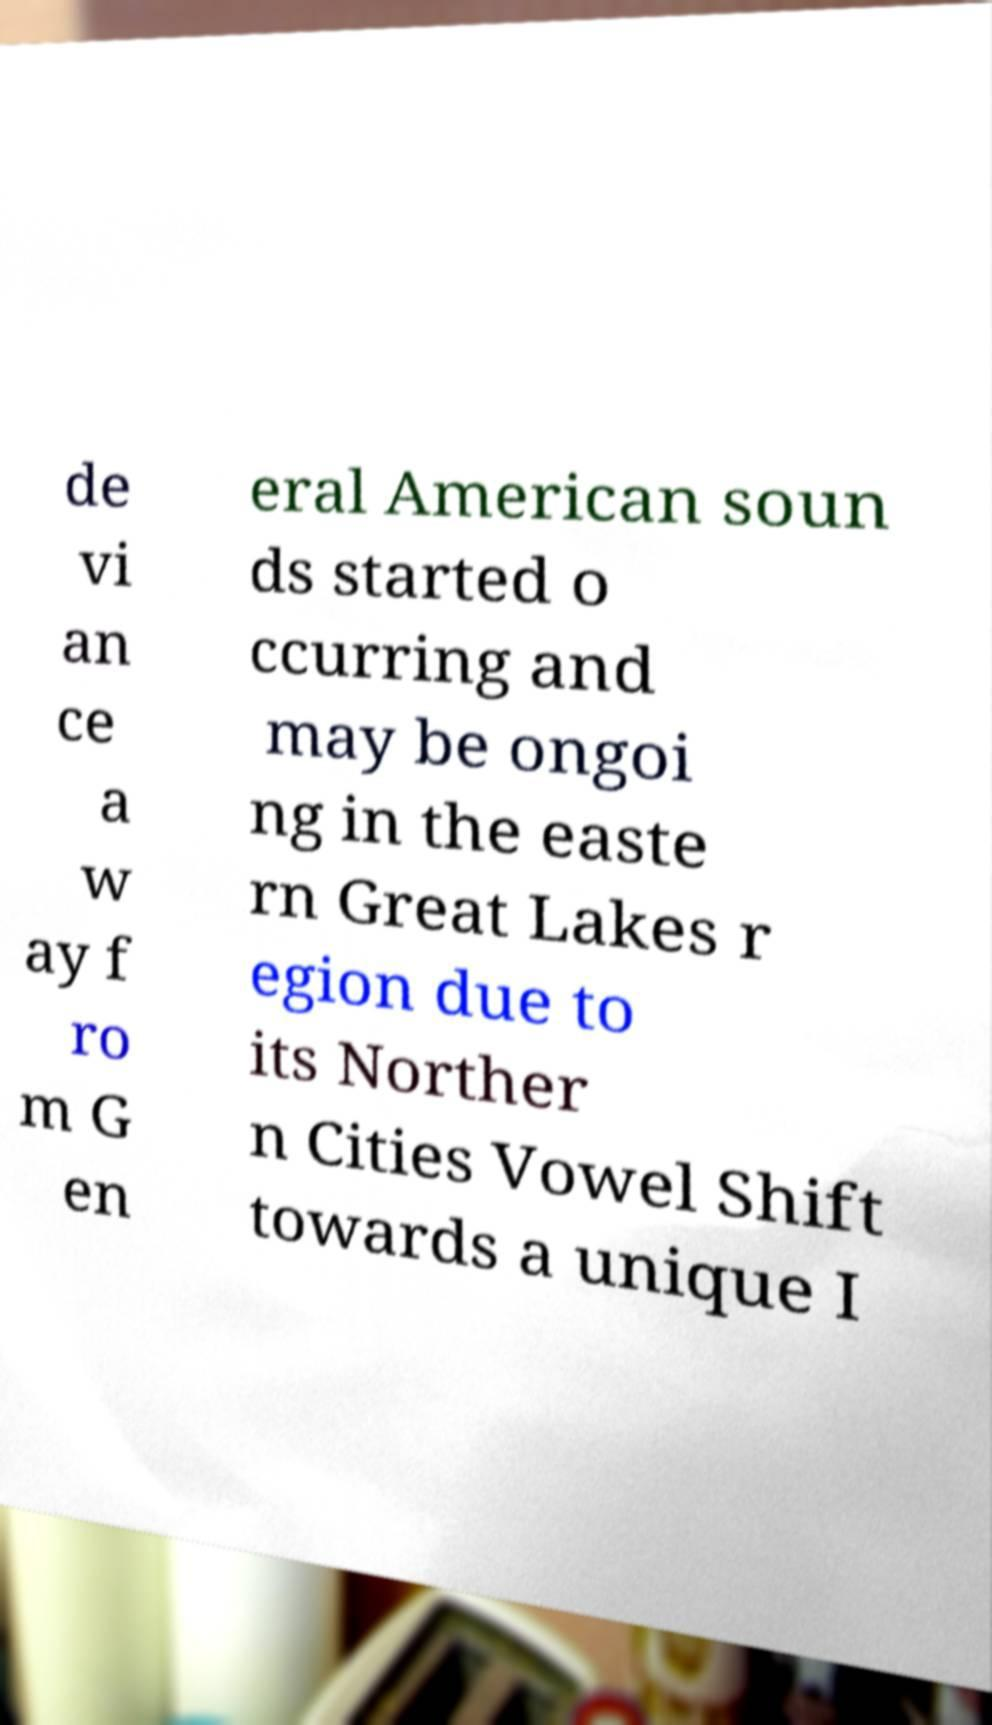What messages or text are displayed in this image? I need them in a readable, typed format. de vi an ce a w ay f ro m G en eral American soun ds started o ccurring and may be ongoi ng in the easte rn Great Lakes r egion due to its Norther n Cities Vowel Shift towards a unique I 